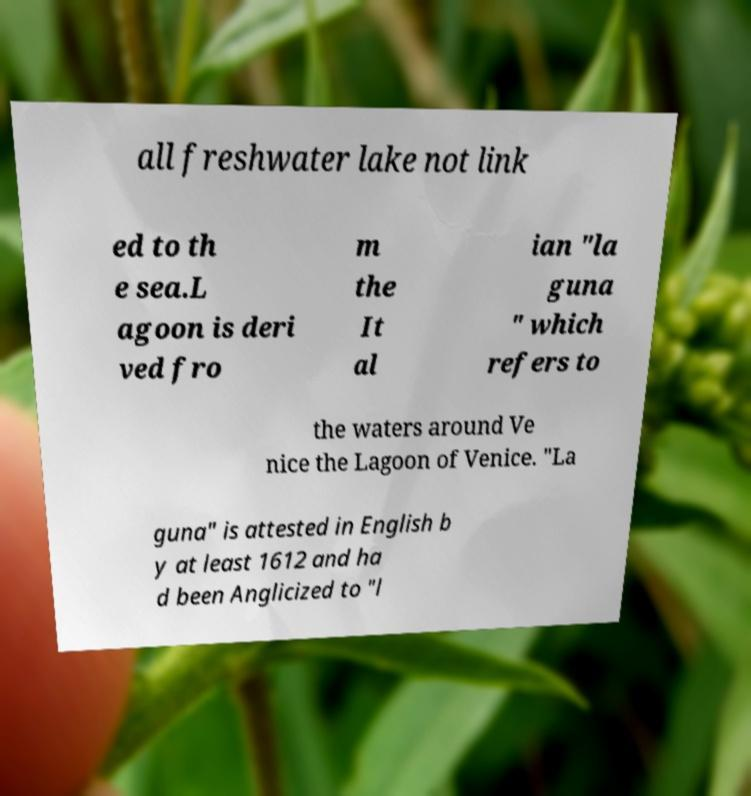For documentation purposes, I need the text within this image transcribed. Could you provide that? all freshwater lake not link ed to th e sea.L agoon is deri ved fro m the It al ian "la guna " which refers to the waters around Ve nice the Lagoon of Venice. "La guna" is attested in English b y at least 1612 and ha d been Anglicized to "l 